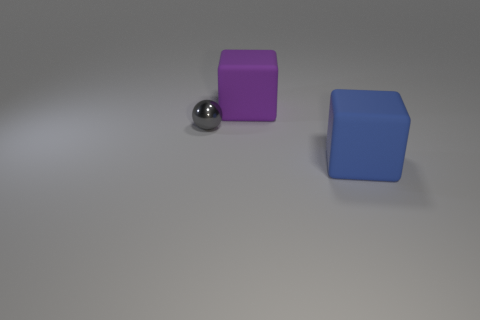Are there any other things that are the same size as the gray thing?
Provide a short and direct response. No. Are the tiny sphere and the blue object made of the same material?
Your response must be concise. No. What number of other blue objects are the same material as the tiny object?
Your response must be concise. 0. What number of things are matte cubes that are in front of the small shiny object or objects that are behind the blue block?
Offer a very short reply. 3. Is the number of matte cubes on the left side of the gray shiny thing greater than the number of purple rubber cubes in front of the large blue block?
Offer a very short reply. No. The big object that is in front of the tiny gray ball is what color?
Ensure brevity in your answer.  Blue. Are there any other blue matte objects of the same shape as the big blue object?
Provide a succinct answer. No. How many gray objects are either small metallic objects or small matte cylinders?
Your answer should be compact. 1. Is there a cube of the same size as the gray shiny ball?
Offer a terse response. No. How many small cyan objects are there?
Ensure brevity in your answer.  0. 